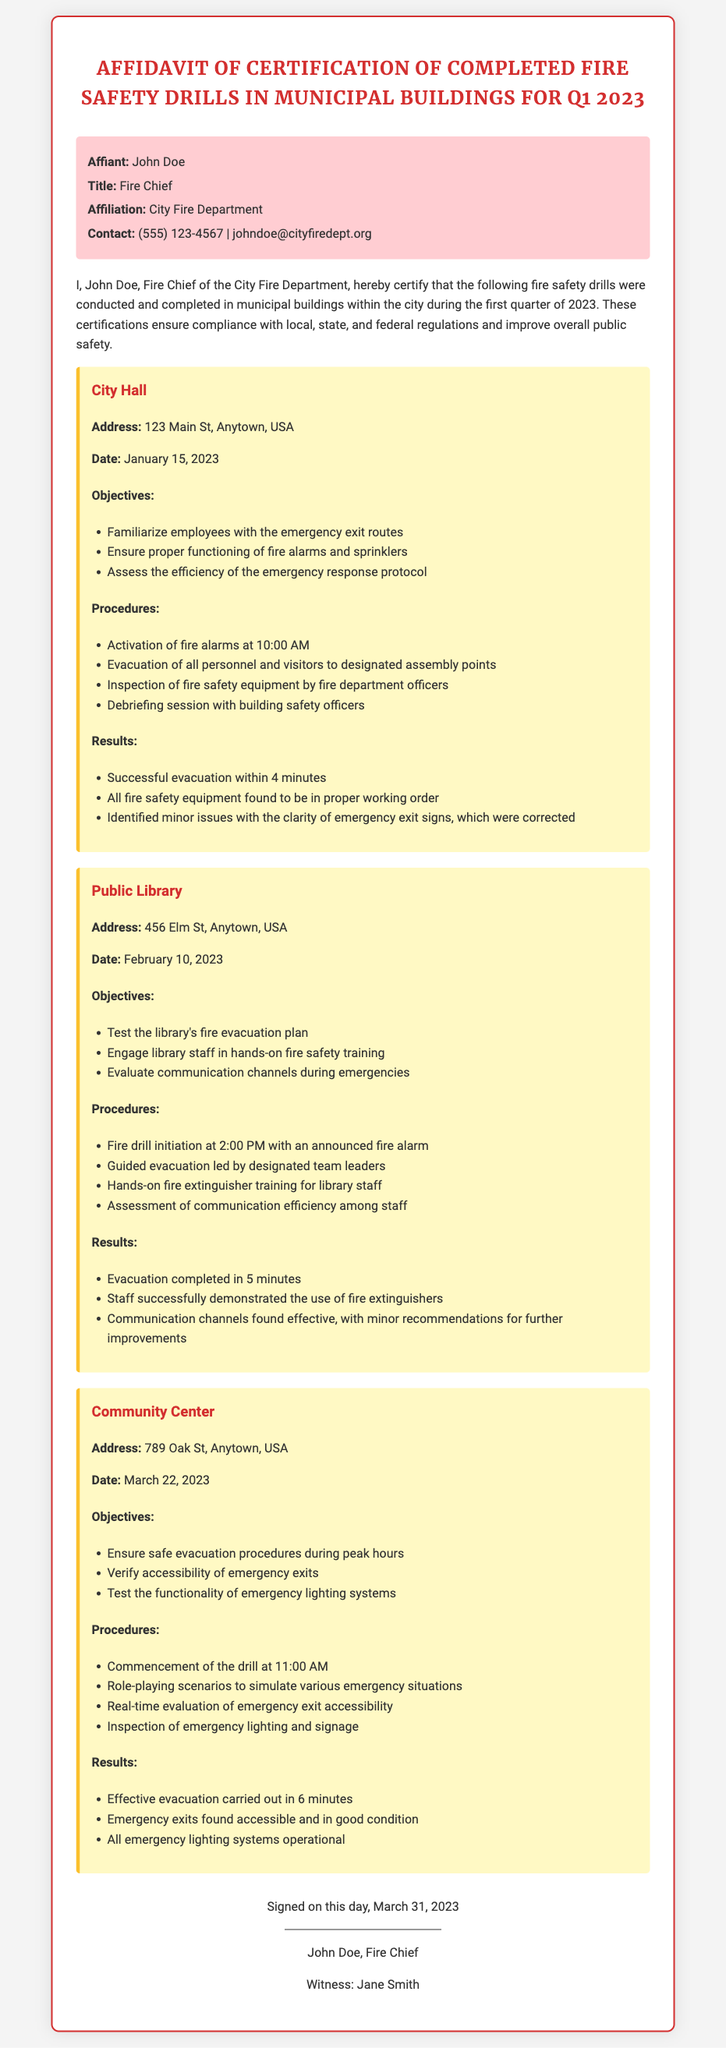What is the name of the affiant? The name of the affiant is stated at the beginning of the affidavit.
Answer: John Doe What is the address of the Public Library? The address is provided under the drill information for the Public Library section.
Answer: 456 Elm St, Anytown, USA On what date was the drill conducted at City Hall? The date of the drill is explicitly mentioned in the drill information for City Hall.
Answer: January 15, 2023 How long did it take to evacuate the Community Center? The evacuation time is mentioned in the results of the drill information for the Community Center.
Answer: 6 minutes What was one objective of the fire drill at the Public Library? One objective is listed in the drill information for the Public Library section.
Answer: Test the library's fire evacuation plan Which fire safety equipment was inspected at City Hall? The type of equipment that was inspected is mentioned in the procedures for City Hall.
Answer: Fire safety equipment What was the completion time for the drill at the Public Library? The completion time is specified in the results of the drill information for the Public Library.
Answer: 5 minutes What is the role of Jane Smith in the affidavit? Her role is identified in the signature section of the affidavit.
Answer: Witness What color is used for the container of the affidavit? The color of the container is described in the document’s style section.
Answer: White 